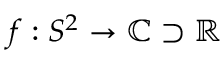Convert formula to latex. <formula><loc_0><loc_0><loc_500><loc_500>f \colon S ^ { 2 } \to \mathbb { C } \supset \mathbb { R }</formula> 